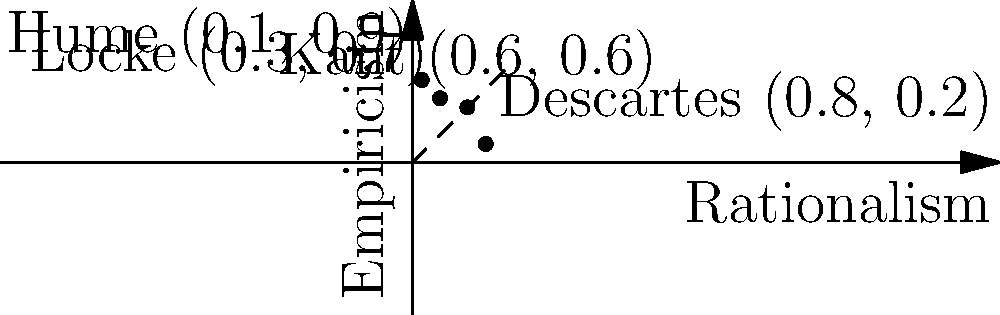In the given 2D vector space representation of philosophical epistemologies, where the x-axis represents Rationalism and the y-axis represents Empiricism, which philosopher's position is closest to a perfect balance between these two approaches? Explain your reasoning using vector analysis. To determine which philosopher's position is closest to a perfect balance between Rationalism and Empiricism, we need to follow these steps:

1. Identify the point of perfect balance:
   The point (0.5, 0.5) would represent an equal emphasis on both Rationalism and Empiricism.

2. Calculate the distance from each philosopher's position to the point (0.5, 0.5):
   We can use the distance formula: $d = \sqrt{(x_2-x_1)^2 + (y_2-y_1)^2}$

   For Descartes (0.8, 0.2):
   $d_D = \sqrt{(0.8-0.5)^2 + (0.2-0.5)^2} = \sqrt{0.3^2 + (-0.3)^2} = \sqrt{0.18} \approx 0.42$

   For Locke (0.3, 0.7):
   $d_L = \sqrt{(0.3-0.5)^2 + (0.7-0.5)^2} = \sqrt{(-0.2)^2 + 0.2^2} = \sqrt{0.08} \approx 0.28$

   For Kant (0.6, 0.6):
   $d_K = \sqrt{(0.6-0.5)^2 + (0.6-0.5)^2} = \sqrt{0.1^2 + 0.1^2} = \sqrt{0.02} \approx 0.14$

   For Hume (0.1, 0.9):
   $d_H = \sqrt{(0.1-0.5)^2 + (0.9-0.5)^2} = \sqrt{(-0.4)^2 + 0.4^2} = \sqrt{0.32} \approx 0.57$

3. Compare the distances:
   Kant has the smallest distance (0.14) to the point of perfect balance (0.5, 0.5).

Therefore, Kant's position is closest to a perfect balance between Rationalism and Empiricism in this representation.
Answer: Kant 